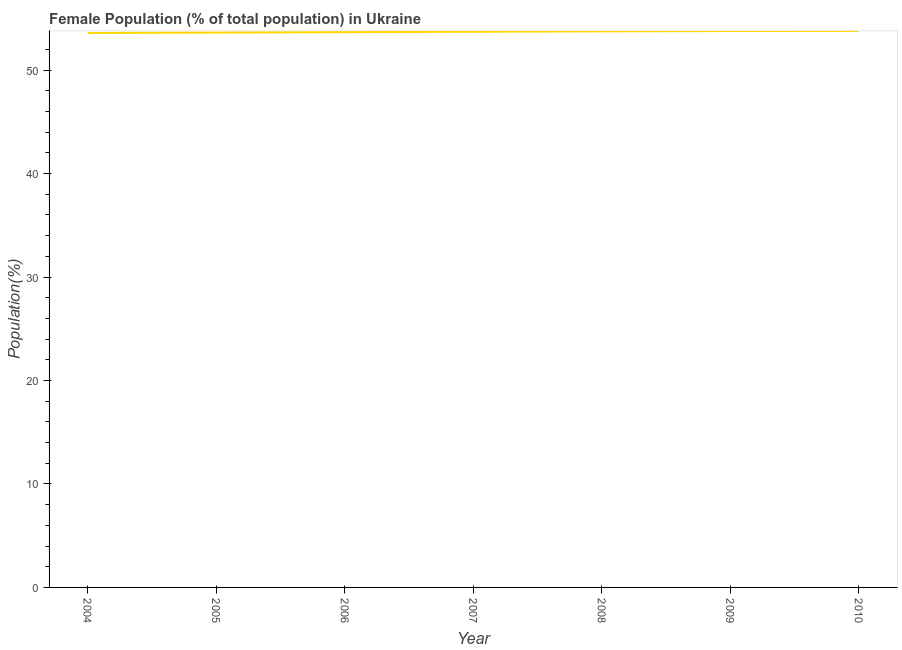What is the female population in 2009?
Provide a succinct answer. 53.77. Across all years, what is the maximum female population?
Offer a terse response. 53.79. Across all years, what is the minimum female population?
Make the answer very short. 53.59. What is the sum of the female population?
Ensure brevity in your answer.  375.9. What is the difference between the female population in 2004 and 2008?
Offer a terse response. -0.16. What is the average female population per year?
Your answer should be very brief. 53.7. What is the median female population?
Provide a short and direct response. 53.71. Do a majority of the years between 2009 and 2008 (inclusive) have female population greater than 46 %?
Ensure brevity in your answer.  No. What is the ratio of the female population in 2005 to that in 2008?
Make the answer very short. 1. Is the difference between the female population in 2006 and 2007 greater than the difference between any two years?
Ensure brevity in your answer.  No. What is the difference between the highest and the second highest female population?
Your response must be concise. 0.01. What is the difference between the highest and the lowest female population?
Provide a succinct answer. 0.2. Are the values on the major ticks of Y-axis written in scientific E-notation?
Provide a short and direct response. No. Does the graph contain any zero values?
Make the answer very short. No. Does the graph contain grids?
Offer a very short reply. No. What is the title of the graph?
Your answer should be compact. Female Population (% of total population) in Ukraine. What is the label or title of the X-axis?
Give a very brief answer. Year. What is the label or title of the Y-axis?
Your response must be concise. Population(%). What is the Population(%) of 2004?
Provide a short and direct response. 53.59. What is the Population(%) in 2005?
Offer a terse response. 53.63. What is the Population(%) of 2006?
Your response must be concise. 53.67. What is the Population(%) in 2007?
Provide a short and direct response. 53.71. What is the Population(%) in 2008?
Your answer should be very brief. 53.75. What is the Population(%) of 2009?
Your answer should be compact. 53.77. What is the Population(%) in 2010?
Offer a very short reply. 53.79. What is the difference between the Population(%) in 2004 and 2005?
Give a very brief answer. -0.04. What is the difference between the Population(%) in 2004 and 2006?
Provide a short and direct response. -0.08. What is the difference between the Population(%) in 2004 and 2007?
Provide a short and direct response. -0.12. What is the difference between the Population(%) in 2004 and 2008?
Provide a short and direct response. -0.16. What is the difference between the Population(%) in 2004 and 2009?
Your answer should be compact. -0.19. What is the difference between the Population(%) in 2004 and 2010?
Give a very brief answer. -0.2. What is the difference between the Population(%) in 2005 and 2006?
Provide a succinct answer. -0.04. What is the difference between the Population(%) in 2005 and 2007?
Your response must be concise. -0.08. What is the difference between the Population(%) in 2005 and 2008?
Your response must be concise. -0.12. What is the difference between the Population(%) in 2005 and 2009?
Your answer should be very brief. -0.15. What is the difference between the Population(%) in 2005 and 2010?
Your response must be concise. -0.16. What is the difference between the Population(%) in 2006 and 2007?
Make the answer very short. -0.04. What is the difference between the Population(%) in 2006 and 2008?
Your response must be concise. -0.08. What is the difference between the Population(%) in 2006 and 2009?
Offer a terse response. -0.11. What is the difference between the Population(%) in 2006 and 2010?
Offer a very short reply. -0.12. What is the difference between the Population(%) in 2007 and 2008?
Offer a terse response. -0.04. What is the difference between the Population(%) in 2007 and 2009?
Provide a short and direct response. -0.07. What is the difference between the Population(%) in 2007 and 2010?
Provide a short and direct response. -0.08. What is the difference between the Population(%) in 2008 and 2009?
Give a very brief answer. -0.03. What is the difference between the Population(%) in 2008 and 2010?
Ensure brevity in your answer.  -0.04. What is the difference between the Population(%) in 2009 and 2010?
Your response must be concise. -0.01. What is the ratio of the Population(%) in 2004 to that in 2005?
Your answer should be very brief. 1. What is the ratio of the Population(%) in 2004 to that in 2008?
Offer a terse response. 1. What is the ratio of the Population(%) in 2004 to that in 2009?
Your answer should be compact. 1. What is the ratio of the Population(%) in 2004 to that in 2010?
Your answer should be compact. 1. What is the ratio of the Population(%) in 2005 to that in 2007?
Provide a succinct answer. 1. What is the ratio of the Population(%) in 2005 to that in 2008?
Your answer should be compact. 1. What is the ratio of the Population(%) in 2005 to that in 2009?
Your answer should be very brief. 1. What is the ratio of the Population(%) in 2006 to that in 2007?
Offer a very short reply. 1. What is the ratio of the Population(%) in 2006 to that in 2010?
Provide a short and direct response. 1. 